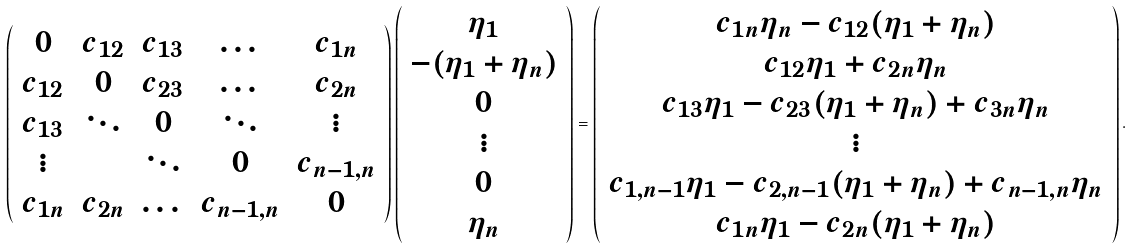<formula> <loc_0><loc_0><loc_500><loc_500>\left ( \begin{array} { c c c c c } 0 & c _ { 1 2 } & c _ { 1 3 } & \dots & c _ { 1 n } \\ c _ { 1 2 } & 0 & c _ { 2 3 } & \dots & c _ { 2 n } \\ c _ { 1 3 } & \ddots & 0 & \ddots & \vdots \\ \vdots & & \ddots & 0 & c _ { n - 1 , n } \\ c _ { 1 n } & c _ { 2 n } & \dots & c _ { n - 1 , n } & 0 \\ \end{array} \right ) \left ( \begin{array} { c } \eta _ { 1 } \\ - ( \eta _ { 1 } + \eta _ { n } ) \\ 0 \\ \vdots \\ 0 \\ \eta _ { n } \\ \end{array} \right ) = \left ( \begin{array} { c } c _ { 1 n } \eta _ { n } - c _ { 1 2 } ( \eta _ { 1 } + \eta _ { n } ) \\ c _ { 1 2 } \eta _ { 1 } + c _ { 2 n } \eta _ { n } \\ c _ { 1 3 } \eta _ { 1 } - c _ { 2 3 } ( \eta _ { 1 } + \eta _ { n } ) + c _ { 3 n } \eta _ { n } \\ \vdots \\ c _ { 1 , n - 1 } \eta _ { 1 } - c _ { 2 , n - 1 } ( \eta _ { 1 } + \eta _ { n } ) + c _ { n - 1 , n } \eta _ { n } \\ c _ { 1 n } \eta _ { 1 } - c _ { 2 n } ( \eta _ { 1 } + \eta _ { n } ) \\ \end{array} \right ) .</formula> 